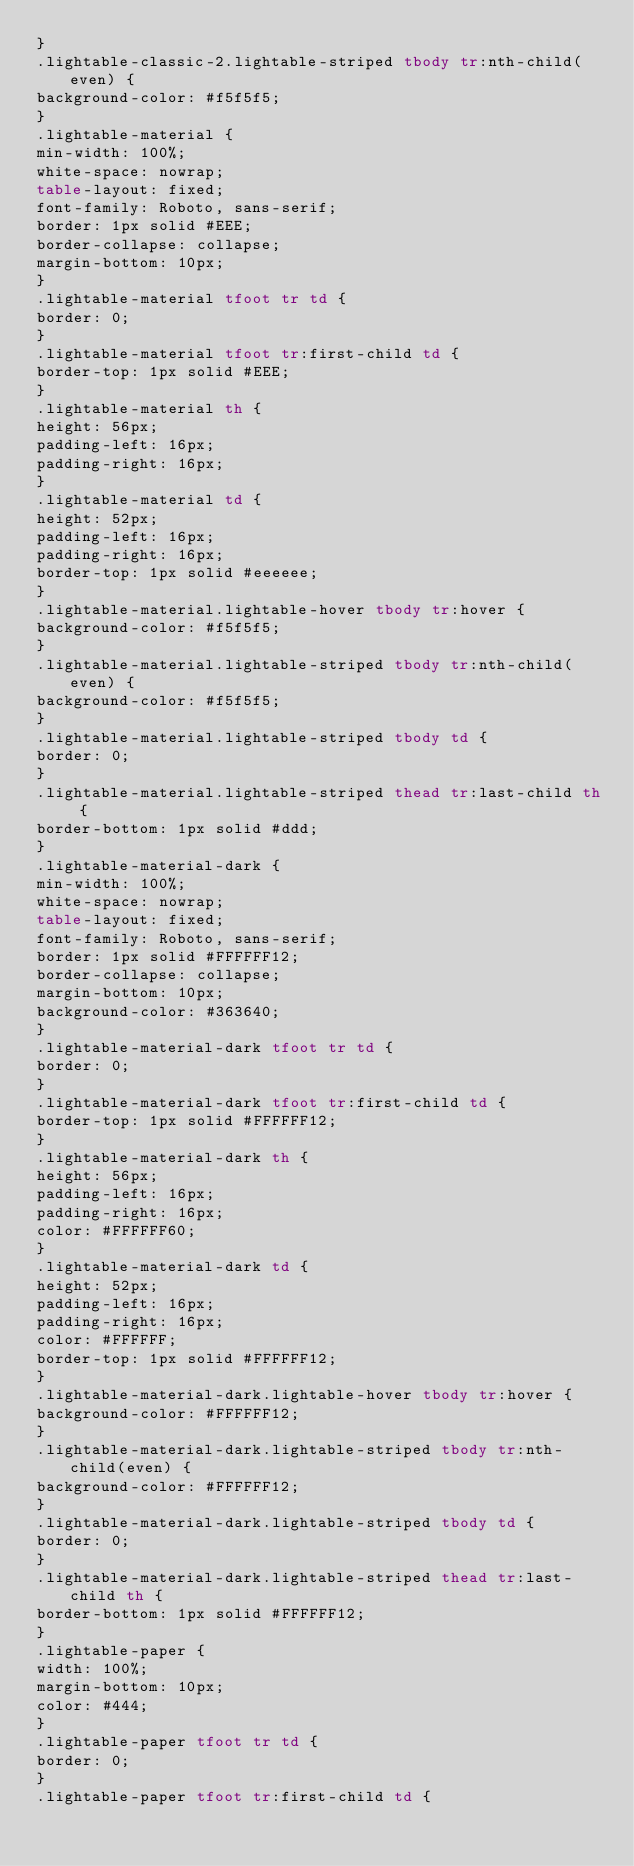Convert code to text. <code><loc_0><loc_0><loc_500><loc_500><_HTML_>}
.lightable-classic-2.lightable-striped tbody tr:nth-child(even) {
background-color: #f5f5f5;
}
.lightable-material {
min-width: 100%;
white-space: nowrap;
table-layout: fixed;
font-family: Roboto, sans-serif;
border: 1px solid #EEE;
border-collapse: collapse;
margin-bottom: 10px;
}
.lightable-material tfoot tr td {
border: 0;
}
.lightable-material tfoot tr:first-child td {
border-top: 1px solid #EEE;
}
.lightable-material th {
height: 56px;
padding-left: 16px;
padding-right: 16px;
}
.lightable-material td {
height: 52px;
padding-left: 16px;
padding-right: 16px;
border-top: 1px solid #eeeeee;
}
.lightable-material.lightable-hover tbody tr:hover {
background-color: #f5f5f5;
}
.lightable-material.lightable-striped tbody tr:nth-child(even) {
background-color: #f5f5f5;
}
.lightable-material.lightable-striped tbody td {
border: 0;
}
.lightable-material.lightable-striped thead tr:last-child th {
border-bottom: 1px solid #ddd;
}
.lightable-material-dark {
min-width: 100%;
white-space: nowrap;
table-layout: fixed;
font-family: Roboto, sans-serif;
border: 1px solid #FFFFFF12;
border-collapse: collapse;
margin-bottom: 10px;
background-color: #363640;
}
.lightable-material-dark tfoot tr td {
border: 0;
}
.lightable-material-dark tfoot tr:first-child td {
border-top: 1px solid #FFFFFF12;
}
.lightable-material-dark th {
height: 56px;
padding-left: 16px;
padding-right: 16px;
color: #FFFFFF60;
}
.lightable-material-dark td {
height: 52px;
padding-left: 16px;
padding-right: 16px;
color: #FFFFFF;
border-top: 1px solid #FFFFFF12;
}
.lightable-material-dark.lightable-hover tbody tr:hover {
background-color: #FFFFFF12;
}
.lightable-material-dark.lightable-striped tbody tr:nth-child(even) {
background-color: #FFFFFF12;
}
.lightable-material-dark.lightable-striped tbody td {
border: 0;
}
.lightable-material-dark.lightable-striped thead tr:last-child th {
border-bottom: 1px solid #FFFFFF12;
}
.lightable-paper {
width: 100%;
margin-bottom: 10px;
color: #444;
}
.lightable-paper tfoot tr td {
border: 0;
}
.lightable-paper tfoot tr:first-child td {</code> 